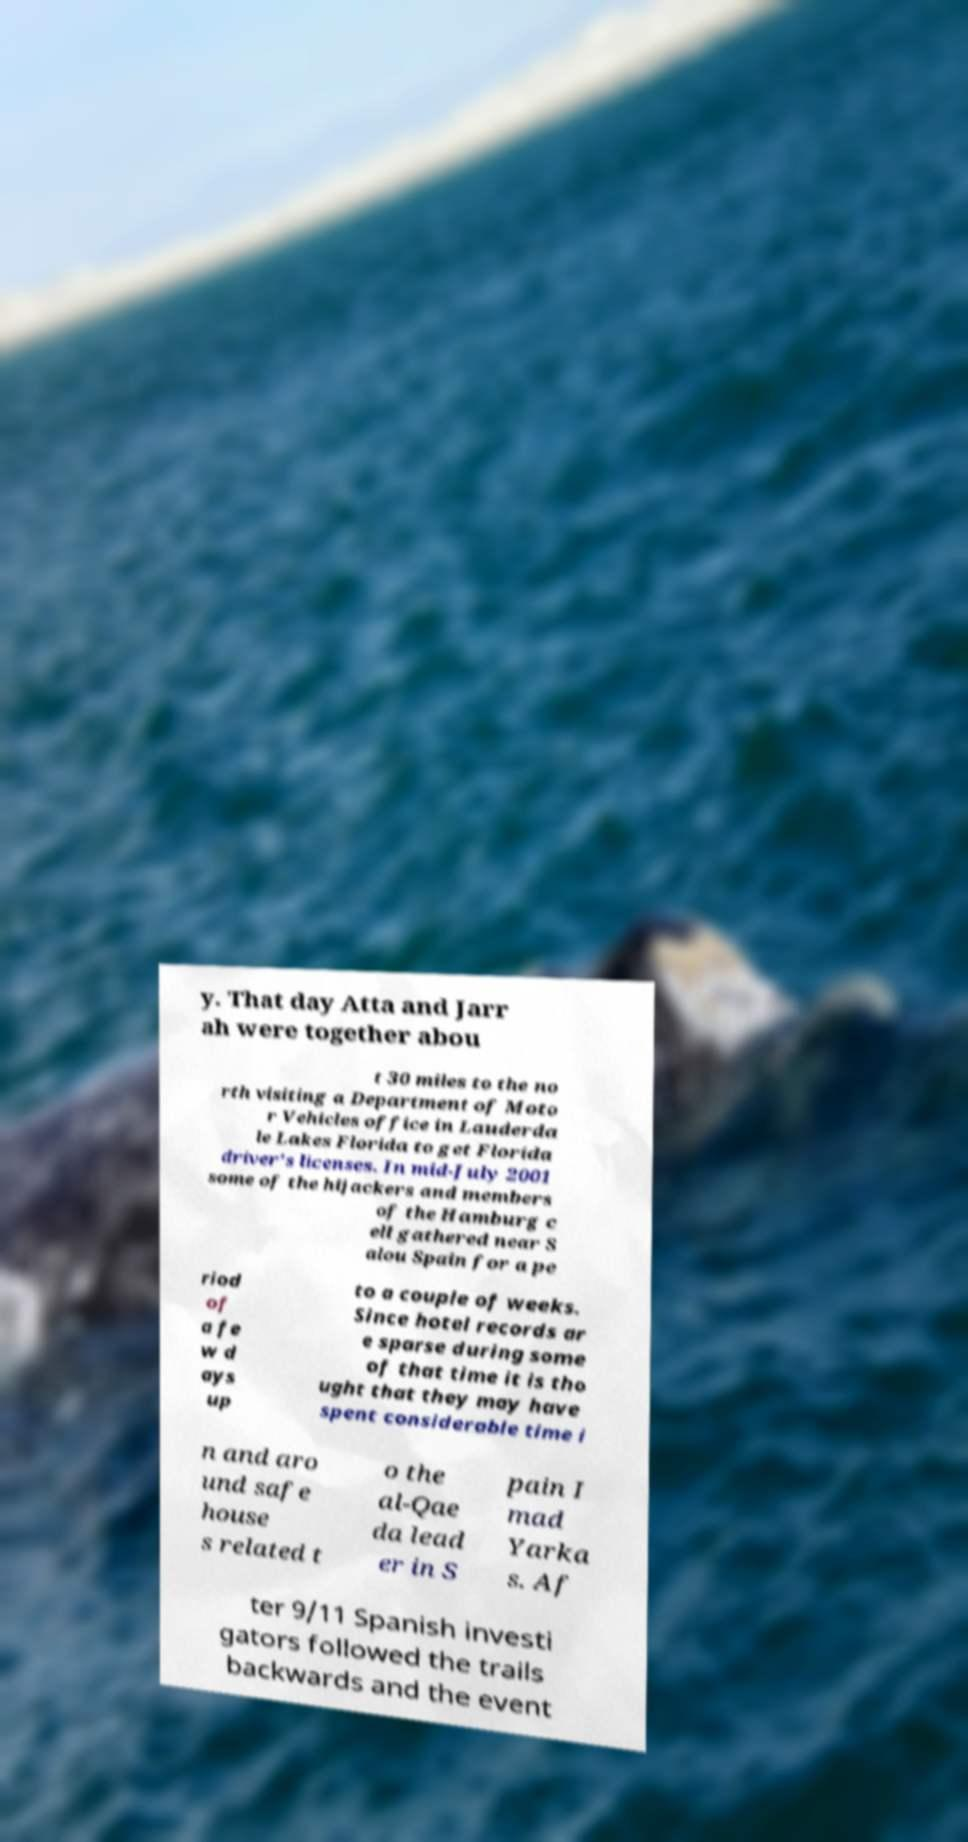There's text embedded in this image that I need extracted. Can you transcribe it verbatim? y. That day Atta and Jarr ah were together abou t 30 miles to the no rth visiting a Department of Moto r Vehicles office in Lauderda le Lakes Florida to get Florida driver's licenses. In mid-July 2001 some of the hijackers and members of the Hamburg c ell gathered near S alou Spain for a pe riod of a fe w d ays up to a couple of weeks. Since hotel records ar e sparse during some of that time it is tho ught that they may have spent considerable time i n and aro und safe house s related t o the al-Qae da lead er in S pain I mad Yarka s. Af ter 9/11 Spanish investi gators followed the trails backwards and the event 